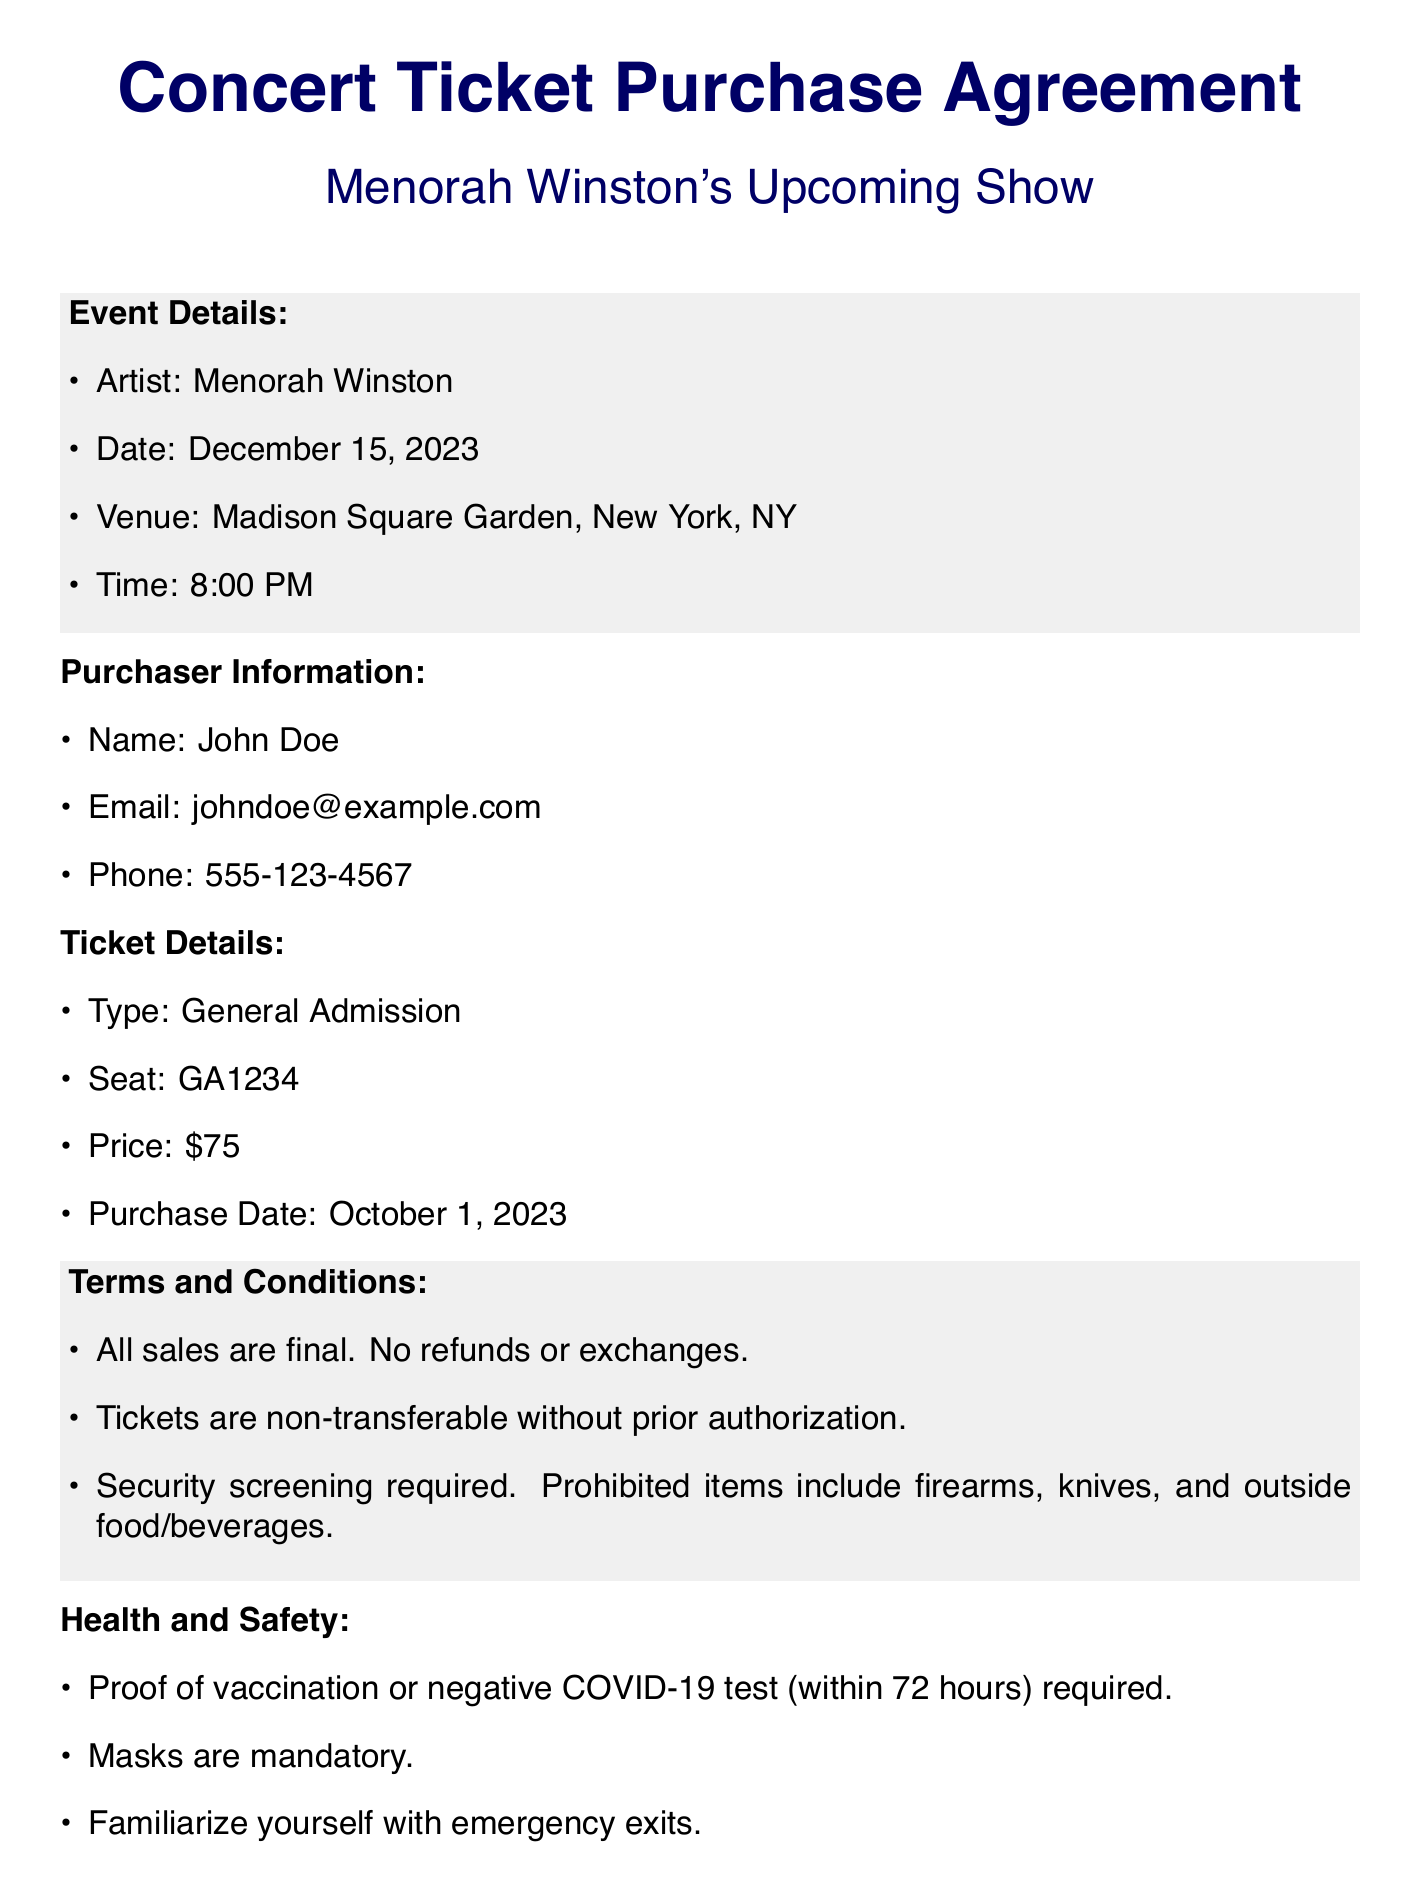what is the artist's name? The artist performing at the event is mentioned in the concert ticket purchase agreement.
Answer: Menorah Winston what is the date of the concert? The date of the concert is stated in the event details section of the document.
Answer: December 15, 2023 what type of ticket was purchased? The type of ticket purchased is explicitly listed under ticket details.
Answer: General Admission what is the price of the ticket? The price of the ticket can be found in the ticket details section of the document.
Answer: $75 what is the venue for the concert? The venue where the concert will take place is listed in the event details.
Answer: Madison Square Garden what is required for entry regarding health and safety? The health and safety requirements are outlined in the respective section of the document.
Answer: Proof of vaccination or negative COVID-19 test how can disputes be resolved according to the agreement? The document states how disputes will be handled concerning legal jurisdiction and methods.
Answer: Binding arbitration what is the purchaser's name? The purchaser's name is provided under the purchaser information section of the document.
Answer: John Doe what is the contact email for customer service? The email address for customer service is located in the contact information section.
Answer: support@menorahwinston.com what is the purchase date of the ticket? The purchase date can be found in the ticket details.
Answer: October 1, 2023 